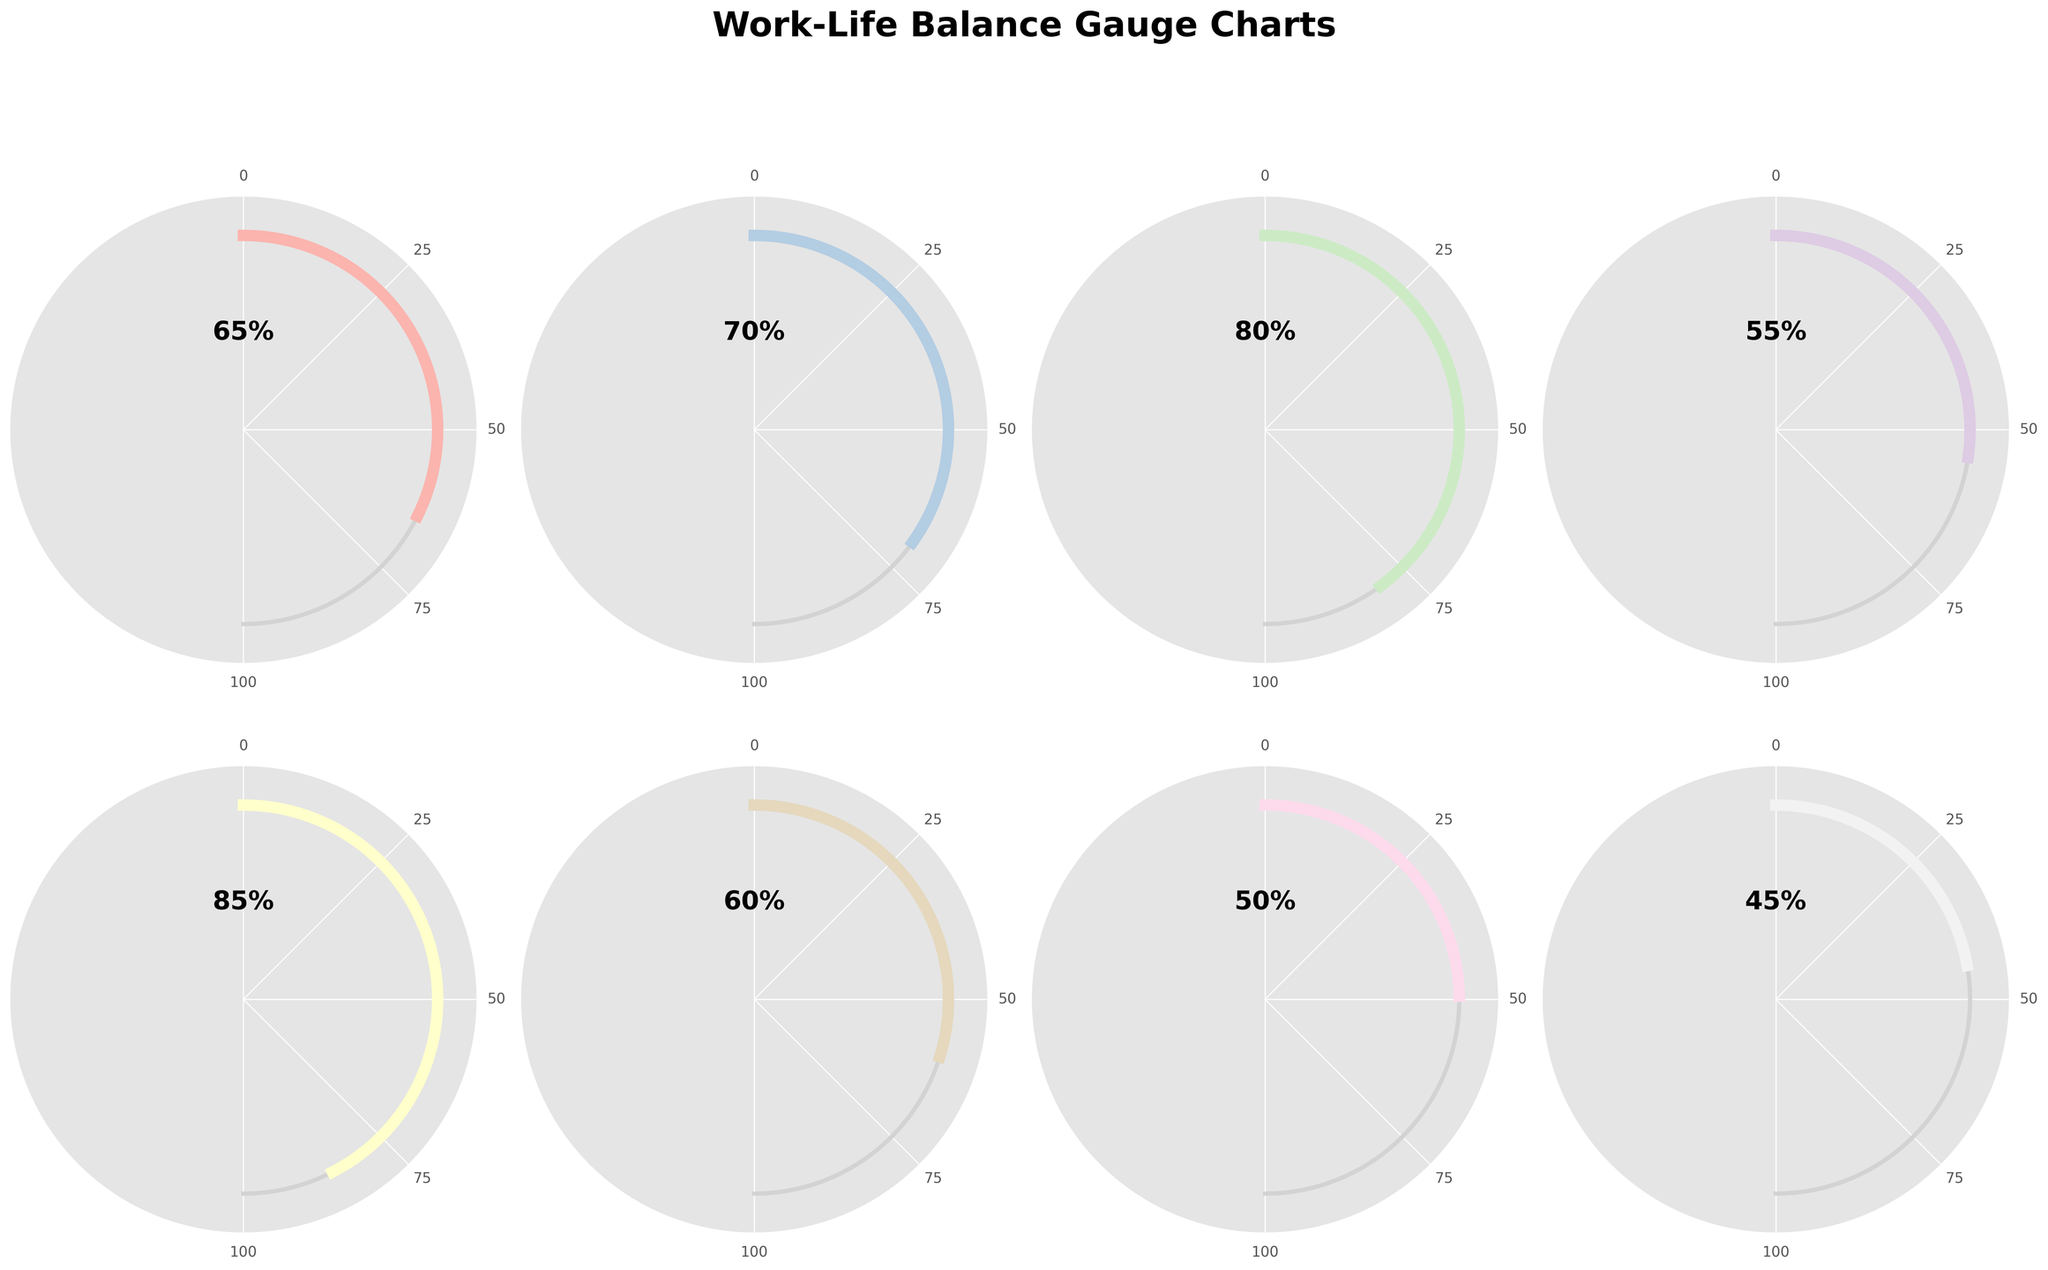What is the overall work-life balance satisfaction score? The overall work-life balance satisfaction score is displayed in one of the gauge charts. It is labeled "Overall Work-Life Balance" and its value is indicated by the gauge.
Answer: 65% Which category has the highest satisfaction score? To determine the category with the highest satisfaction score, look at the gauge chart with the highest value. The chart labeled "Child's Speech Therapy" has the highest value.
Answer: Child's Speech Therapy What are the categories with satisfaction scores greater than 60%? Categories with satisfaction scores greater than 60% can be identified by examining the gauges with values higher than 60%. The categories are "Writing Time" (70%), "Family Time" (80%), and "Child's Speech Therapy" (85%).
Answer: Writing Time, Family Time, Child's Speech Therapy How does the satisfaction score for Writing Time compare to Career Development? The satisfaction score for Writing Time is 70%, while that for Career Development is 45%. By comparing these two values, Writing Time has a higher satisfaction score.
Answer: Writing Time has a higher score (70% vs 45%) What is the average satisfaction score of all categories? To find the average satisfaction score, sum all the values and divide by the number of categories:
(65 + 70 + 80 + 55 + 85 + 60 + 50 + 45) / 8 = 510 / 8 = 63.75
Answer: 63.75% Which category has the lowest satisfaction score, and what is its value? The category with the lowest satisfaction score is identified by the gauge with the smallest value. The chart labeled "Career Development" has the lowest score of 45%.
Answer: Career Development, 45% What is the difference in satisfaction scores between Self-Care and Household Management? To find the difference, subtract the value of Household Management (60%) from the value of Self-Care (55%):
Self-Care (55%) - Household Management (60%) = -5%
Answer: -5% How many categories have a satisfaction score below 60%? Count the gauge charts that have values below 60%. The categories are "Self-Care" (55%), "Professional Networking" (50%), and "Career Development" (45%), so there are three such categories.
Answer: 3 If you improved the satisfaction score of Household Management by 10 percentage points, what would the new score be? The current satisfaction score of Household Management is 60%. Adding 10 percentage points results in:
60% + 10% = 70%
Answer: 70% What is the total value sum of Family Time and Child's Speech Therapy satisfaction scores? To find the total value, add the satisfaction scores of both categories:
"Family Time" (80%) + "Child's Speech Therapy" (85%) = 165%
Answer: 165% 